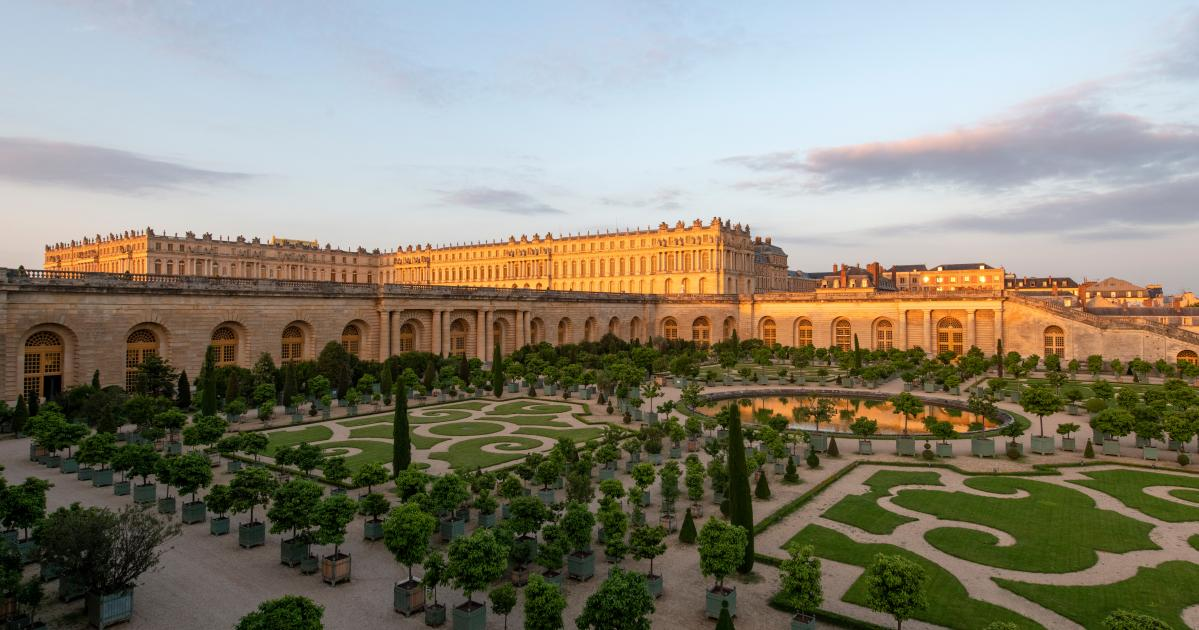Describe the architectural style of the palace in the image. The architectural style of the palace in the image is quintessentially Baroque, characterized by its grandiose scale, elaborate ornamentation, and symmetry. The facade features classic columns, arches, and a plethora of windows that allow natural light to flood the interior. The extensive use of symmetry and geometric shapes in both the palace and the surrounding gardens reflects the Baroque fascination with order and grandeur. 